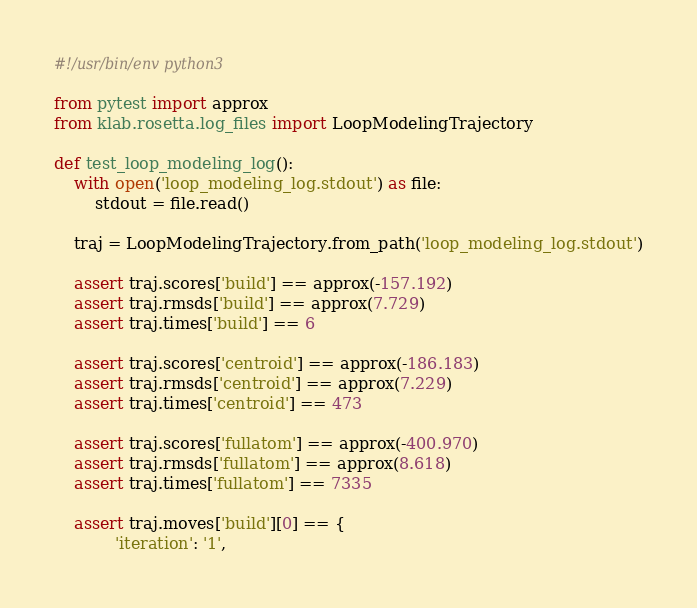<code> <loc_0><loc_0><loc_500><loc_500><_Python_>#!/usr/bin/env python3

from pytest import approx
from klab.rosetta.log_files import LoopModelingTrajectory

def test_loop_modeling_log():
    with open('loop_modeling_log.stdout') as file:
        stdout = file.read()

    traj = LoopModelingTrajectory.from_path('loop_modeling_log.stdout')

    assert traj.scores['build'] == approx(-157.192)
    assert traj.rmsds['build'] == approx(7.729)
    assert traj.times['build'] == 6

    assert traj.scores['centroid'] == approx(-186.183)
    assert traj.rmsds['centroid'] == approx(7.229)
    assert traj.times['centroid'] == 473

    assert traj.scores['fullatom'] == approx(-400.970)
    assert traj.rmsds['fullatom'] == approx(8.618)
    assert traj.times['fullatom'] == 7335

    assert traj.moves['build'][0] == {
            'iteration': '1',</code> 